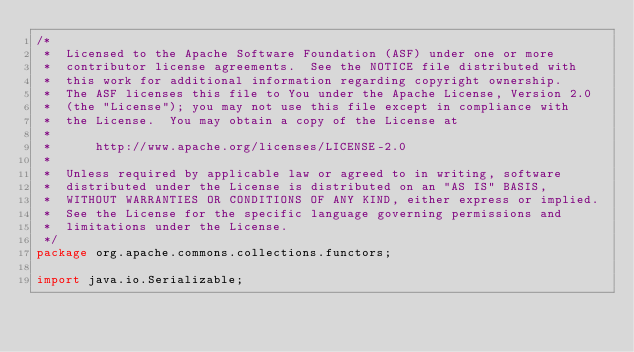<code> <loc_0><loc_0><loc_500><loc_500><_Java_>/*
 *  Licensed to the Apache Software Foundation (ASF) under one or more
 *  contributor license agreements.  See the NOTICE file distributed with
 *  this work for additional information regarding copyright ownership.
 *  The ASF licenses this file to You under the Apache License, Version 2.0
 *  (the "License"); you may not use this file except in compliance with
 *  the License.  You may obtain a copy of the License at
 *
 *      http://www.apache.org/licenses/LICENSE-2.0
 *
 *  Unless required by applicable law or agreed to in writing, software
 *  distributed under the License is distributed on an "AS IS" BASIS,
 *  WITHOUT WARRANTIES OR CONDITIONS OF ANY KIND, either express or implied.
 *  See the License for the specific language governing permissions and
 *  limitations under the License.
 */
package org.apache.commons.collections.functors;

import java.io.Serializable;
</code> 